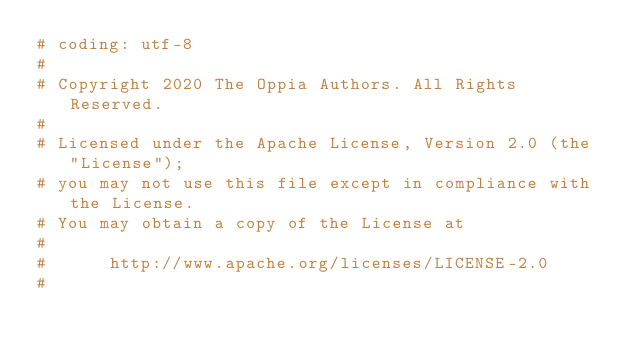<code> <loc_0><loc_0><loc_500><loc_500><_Python_># coding: utf-8
#
# Copyright 2020 The Oppia Authors. All Rights Reserved.
#
# Licensed under the Apache License, Version 2.0 (the "License");
# you may not use this file except in compliance with the License.
# You may obtain a copy of the License at
#
#      http://www.apache.org/licenses/LICENSE-2.0
#</code> 